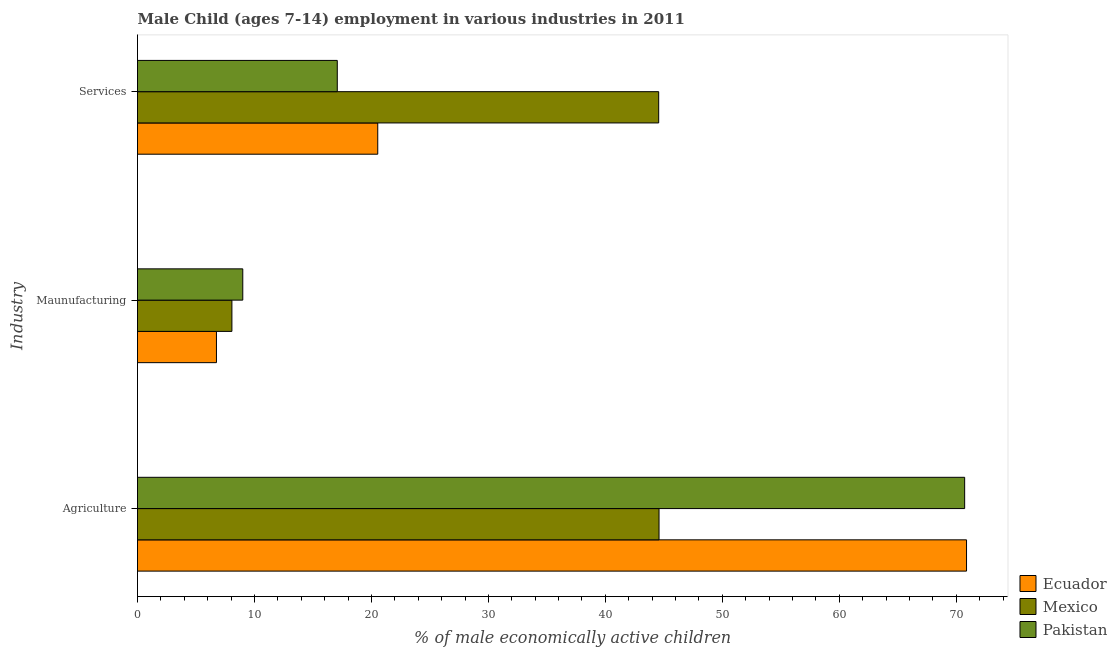How many groups of bars are there?
Provide a succinct answer. 3. Are the number of bars on each tick of the Y-axis equal?
Provide a succinct answer. Yes. How many bars are there on the 2nd tick from the top?
Offer a terse response. 3. What is the label of the 1st group of bars from the top?
Give a very brief answer. Services. What is the percentage of economically active children in agriculture in Mexico?
Ensure brevity in your answer.  44.59. Across all countries, what is the maximum percentage of economically active children in services?
Make the answer very short. 44.56. Across all countries, what is the minimum percentage of economically active children in services?
Offer a very short reply. 17.08. In which country was the percentage of economically active children in manufacturing maximum?
Provide a succinct answer. Pakistan. In which country was the percentage of economically active children in agriculture minimum?
Provide a short and direct response. Mexico. What is the total percentage of economically active children in services in the graph?
Offer a very short reply. 82.18. What is the difference between the percentage of economically active children in services in Ecuador and that in Pakistan?
Keep it short and to the point. 3.46. What is the difference between the percentage of economically active children in services in Ecuador and the percentage of economically active children in agriculture in Pakistan?
Offer a very short reply. -50.18. What is the average percentage of economically active children in agriculture per country?
Provide a succinct answer. 62.06. What is the difference between the percentage of economically active children in manufacturing and percentage of economically active children in agriculture in Pakistan?
Offer a very short reply. -61.72. In how many countries, is the percentage of economically active children in services greater than 2 %?
Your answer should be very brief. 3. What is the ratio of the percentage of economically active children in services in Mexico to that in Ecuador?
Ensure brevity in your answer.  2.17. Is the difference between the percentage of economically active children in services in Pakistan and Mexico greater than the difference between the percentage of economically active children in agriculture in Pakistan and Mexico?
Keep it short and to the point. No. What is the difference between the highest and the second highest percentage of economically active children in manufacturing?
Ensure brevity in your answer.  0.93. What is the difference between the highest and the lowest percentage of economically active children in services?
Keep it short and to the point. 27.48. Is the sum of the percentage of economically active children in services in Mexico and Ecuador greater than the maximum percentage of economically active children in manufacturing across all countries?
Keep it short and to the point. Yes. What does the 2nd bar from the bottom in Services represents?
Your answer should be very brief. Mexico. How many bars are there?
Offer a very short reply. 9. Are all the bars in the graph horizontal?
Your response must be concise. Yes. How many countries are there in the graph?
Keep it short and to the point. 3. Are the values on the major ticks of X-axis written in scientific E-notation?
Ensure brevity in your answer.  No. How many legend labels are there?
Provide a short and direct response. 3. How are the legend labels stacked?
Ensure brevity in your answer.  Vertical. What is the title of the graph?
Your answer should be very brief. Male Child (ages 7-14) employment in various industries in 2011. What is the label or title of the X-axis?
Offer a very short reply. % of male economically active children. What is the label or title of the Y-axis?
Your response must be concise. Industry. What is the % of male economically active children in Ecuador in Agriculture?
Provide a short and direct response. 70.88. What is the % of male economically active children in Mexico in Agriculture?
Your response must be concise. 44.59. What is the % of male economically active children in Pakistan in Agriculture?
Your response must be concise. 70.72. What is the % of male economically active children in Ecuador in Maunufacturing?
Your answer should be compact. 6.75. What is the % of male economically active children in Mexico in Maunufacturing?
Offer a very short reply. 8.07. What is the % of male economically active children in Ecuador in Services?
Make the answer very short. 20.54. What is the % of male economically active children of Mexico in Services?
Offer a terse response. 44.56. What is the % of male economically active children of Pakistan in Services?
Your answer should be very brief. 17.08. Across all Industry, what is the maximum % of male economically active children of Ecuador?
Give a very brief answer. 70.88. Across all Industry, what is the maximum % of male economically active children in Mexico?
Your answer should be very brief. 44.59. Across all Industry, what is the maximum % of male economically active children of Pakistan?
Your response must be concise. 70.72. Across all Industry, what is the minimum % of male economically active children of Ecuador?
Ensure brevity in your answer.  6.75. Across all Industry, what is the minimum % of male economically active children in Mexico?
Provide a short and direct response. 8.07. Across all Industry, what is the minimum % of male economically active children of Pakistan?
Make the answer very short. 9. What is the total % of male economically active children of Ecuador in the graph?
Provide a short and direct response. 98.17. What is the total % of male economically active children in Mexico in the graph?
Provide a short and direct response. 97.22. What is the total % of male economically active children of Pakistan in the graph?
Offer a terse response. 96.8. What is the difference between the % of male economically active children of Ecuador in Agriculture and that in Maunufacturing?
Ensure brevity in your answer.  64.13. What is the difference between the % of male economically active children in Mexico in Agriculture and that in Maunufacturing?
Offer a terse response. 36.52. What is the difference between the % of male economically active children of Pakistan in Agriculture and that in Maunufacturing?
Offer a very short reply. 61.72. What is the difference between the % of male economically active children of Ecuador in Agriculture and that in Services?
Ensure brevity in your answer.  50.34. What is the difference between the % of male economically active children in Mexico in Agriculture and that in Services?
Your answer should be compact. 0.03. What is the difference between the % of male economically active children in Pakistan in Agriculture and that in Services?
Give a very brief answer. 53.64. What is the difference between the % of male economically active children of Ecuador in Maunufacturing and that in Services?
Your answer should be very brief. -13.79. What is the difference between the % of male economically active children in Mexico in Maunufacturing and that in Services?
Your answer should be very brief. -36.49. What is the difference between the % of male economically active children in Pakistan in Maunufacturing and that in Services?
Provide a succinct answer. -8.08. What is the difference between the % of male economically active children in Ecuador in Agriculture and the % of male economically active children in Mexico in Maunufacturing?
Your response must be concise. 62.81. What is the difference between the % of male economically active children in Ecuador in Agriculture and the % of male economically active children in Pakistan in Maunufacturing?
Your answer should be very brief. 61.88. What is the difference between the % of male economically active children of Mexico in Agriculture and the % of male economically active children of Pakistan in Maunufacturing?
Your answer should be compact. 35.59. What is the difference between the % of male economically active children in Ecuador in Agriculture and the % of male economically active children in Mexico in Services?
Provide a succinct answer. 26.32. What is the difference between the % of male economically active children of Ecuador in Agriculture and the % of male economically active children of Pakistan in Services?
Offer a terse response. 53.8. What is the difference between the % of male economically active children in Mexico in Agriculture and the % of male economically active children in Pakistan in Services?
Offer a very short reply. 27.51. What is the difference between the % of male economically active children in Ecuador in Maunufacturing and the % of male economically active children in Mexico in Services?
Keep it short and to the point. -37.81. What is the difference between the % of male economically active children in Ecuador in Maunufacturing and the % of male economically active children in Pakistan in Services?
Make the answer very short. -10.33. What is the difference between the % of male economically active children in Mexico in Maunufacturing and the % of male economically active children in Pakistan in Services?
Keep it short and to the point. -9.01. What is the average % of male economically active children in Ecuador per Industry?
Your answer should be very brief. 32.72. What is the average % of male economically active children of Mexico per Industry?
Offer a terse response. 32.41. What is the average % of male economically active children of Pakistan per Industry?
Ensure brevity in your answer.  32.27. What is the difference between the % of male economically active children of Ecuador and % of male economically active children of Mexico in Agriculture?
Your response must be concise. 26.29. What is the difference between the % of male economically active children in Ecuador and % of male economically active children in Pakistan in Agriculture?
Your answer should be very brief. 0.16. What is the difference between the % of male economically active children of Mexico and % of male economically active children of Pakistan in Agriculture?
Provide a succinct answer. -26.13. What is the difference between the % of male economically active children of Ecuador and % of male economically active children of Mexico in Maunufacturing?
Give a very brief answer. -1.32. What is the difference between the % of male economically active children of Ecuador and % of male economically active children of Pakistan in Maunufacturing?
Keep it short and to the point. -2.25. What is the difference between the % of male economically active children in Mexico and % of male economically active children in Pakistan in Maunufacturing?
Provide a succinct answer. -0.93. What is the difference between the % of male economically active children in Ecuador and % of male economically active children in Mexico in Services?
Provide a short and direct response. -24.02. What is the difference between the % of male economically active children in Ecuador and % of male economically active children in Pakistan in Services?
Provide a succinct answer. 3.46. What is the difference between the % of male economically active children in Mexico and % of male economically active children in Pakistan in Services?
Offer a very short reply. 27.48. What is the ratio of the % of male economically active children in Ecuador in Agriculture to that in Maunufacturing?
Your answer should be very brief. 10.5. What is the ratio of the % of male economically active children of Mexico in Agriculture to that in Maunufacturing?
Ensure brevity in your answer.  5.53. What is the ratio of the % of male economically active children of Pakistan in Agriculture to that in Maunufacturing?
Offer a very short reply. 7.86. What is the ratio of the % of male economically active children of Ecuador in Agriculture to that in Services?
Provide a short and direct response. 3.45. What is the ratio of the % of male economically active children of Pakistan in Agriculture to that in Services?
Your answer should be compact. 4.14. What is the ratio of the % of male economically active children of Ecuador in Maunufacturing to that in Services?
Offer a terse response. 0.33. What is the ratio of the % of male economically active children in Mexico in Maunufacturing to that in Services?
Provide a short and direct response. 0.18. What is the ratio of the % of male economically active children of Pakistan in Maunufacturing to that in Services?
Offer a very short reply. 0.53. What is the difference between the highest and the second highest % of male economically active children of Ecuador?
Make the answer very short. 50.34. What is the difference between the highest and the second highest % of male economically active children of Mexico?
Your answer should be compact. 0.03. What is the difference between the highest and the second highest % of male economically active children of Pakistan?
Your response must be concise. 53.64. What is the difference between the highest and the lowest % of male economically active children of Ecuador?
Provide a short and direct response. 64.13. What is the difference between the highest and the lowest % of male economically active children in Mexico?
Your answer should be very brief. 36.52. What is the difference between the highest and the lowest % of male economically active children in Pakistan?
Offer a terse response. 61.72. 